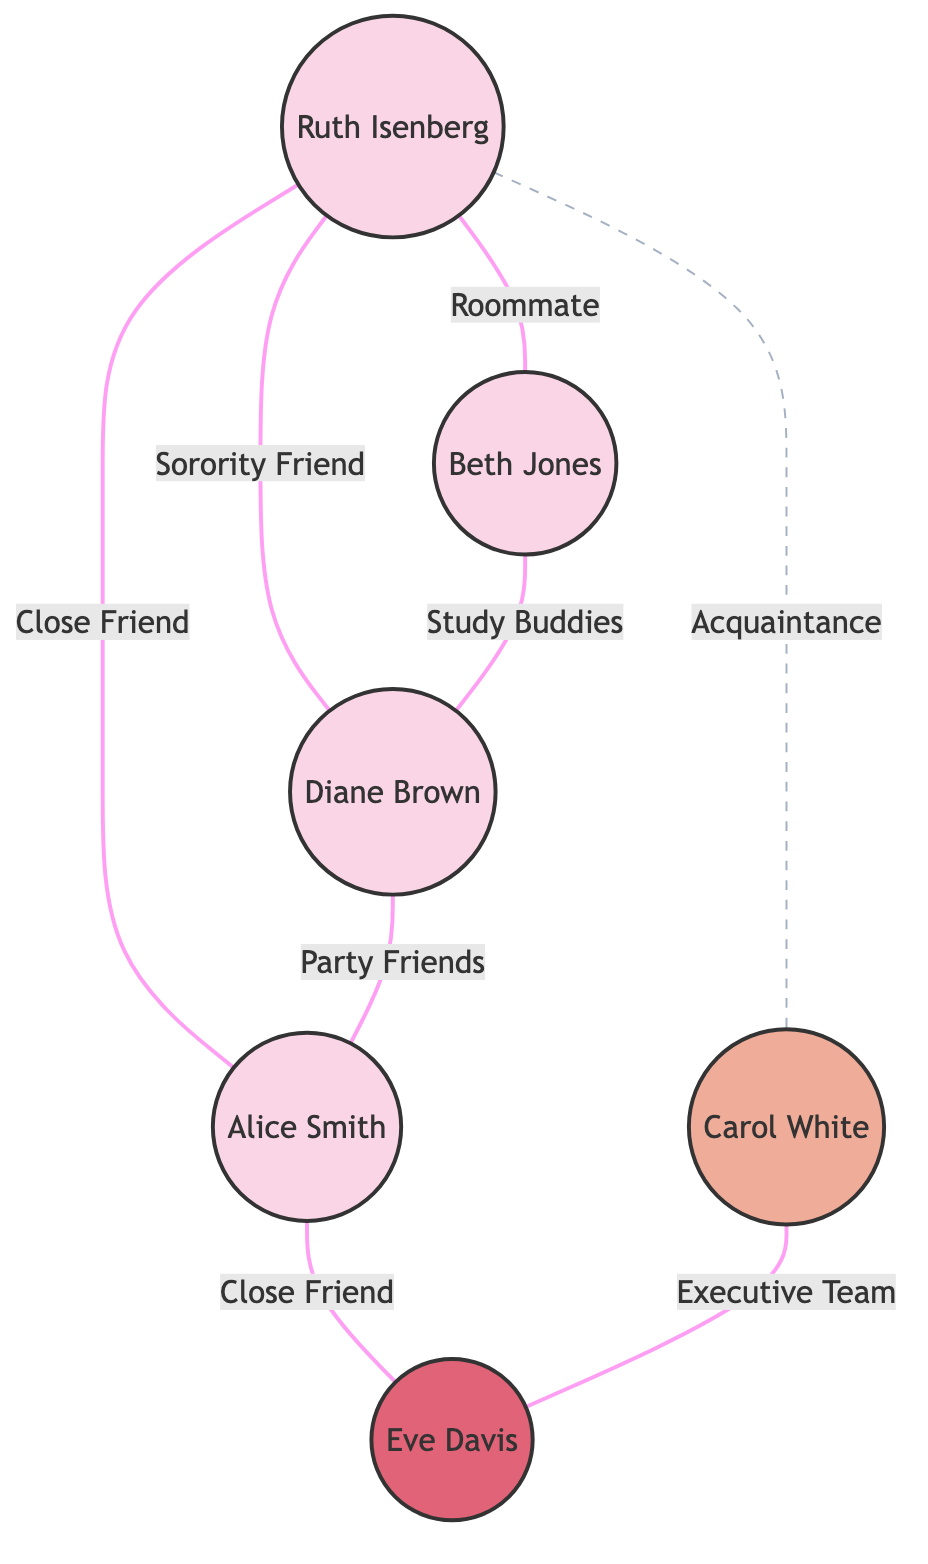What is the total number of members in the diagram? The diagram lists six nodes, each representing a different member of the Kappa Kappa Gamma Sorority: Ruth Isenberg, Alice Smith, Beth Jones, Carol White, Diane Brown, and Eve Davis. Counting these members gives a total of six.
Answer: 6 Who is Ruth Isenberg's closest friend according to the diagram? The link from Ruth Isenberg to Alice Smith is labeled "close_friend," indicating that Alice Smith is Ruth's closest friend among the members in the diagram.
Answer: Alice Smith Which member has the role of President? The role of President is indicated next to Carol White in the nodes section. This information directly identifies Carol White as holding the President role within the sorority.
Answer: Carol White How many different types of relationships are shown in the diagram? The diagram outlines four distinct types of relationships: close_friend, roommate, sorority_friend, and acquaintance. Counting these gives a total of four types of relationships depicted in the connections.
Answer: 4 What is the relationship between Beth Jones and Diane Brown? According to the diagram, there is a link between Beth Jones and Diane Brown labeled "study_buddies," which defines the nature of their relationship. Hence, they have a relationship categorized as study buddies.
Answer: Study buddies Which two members are connected through the executive team relationship? The link between Carol White and Eve Davis is indicated as "executive_team," identifying them as being linked under this specific type of relationship. Therefore, these two members are connected in this way.
Answer: Carol White and Eve Davis How many members did Ruth Isenberg not have a close connection with? Ruth Isenberg has connections with five other members, but two of these connections are not labeled as close relationships. These members are Carol White (acquaintance) and Diane Brown (sorority_friend). Thus, Ruth does not have a close friendship with two members.
Answer: 2 What is the relationship type between Alice Smith and Eve Davis? The connection between Alice Smith and Eve Davis is designated as "close_friend." This label indicates the nature of their relationship as being a close friendship.
Answer: Close friend 